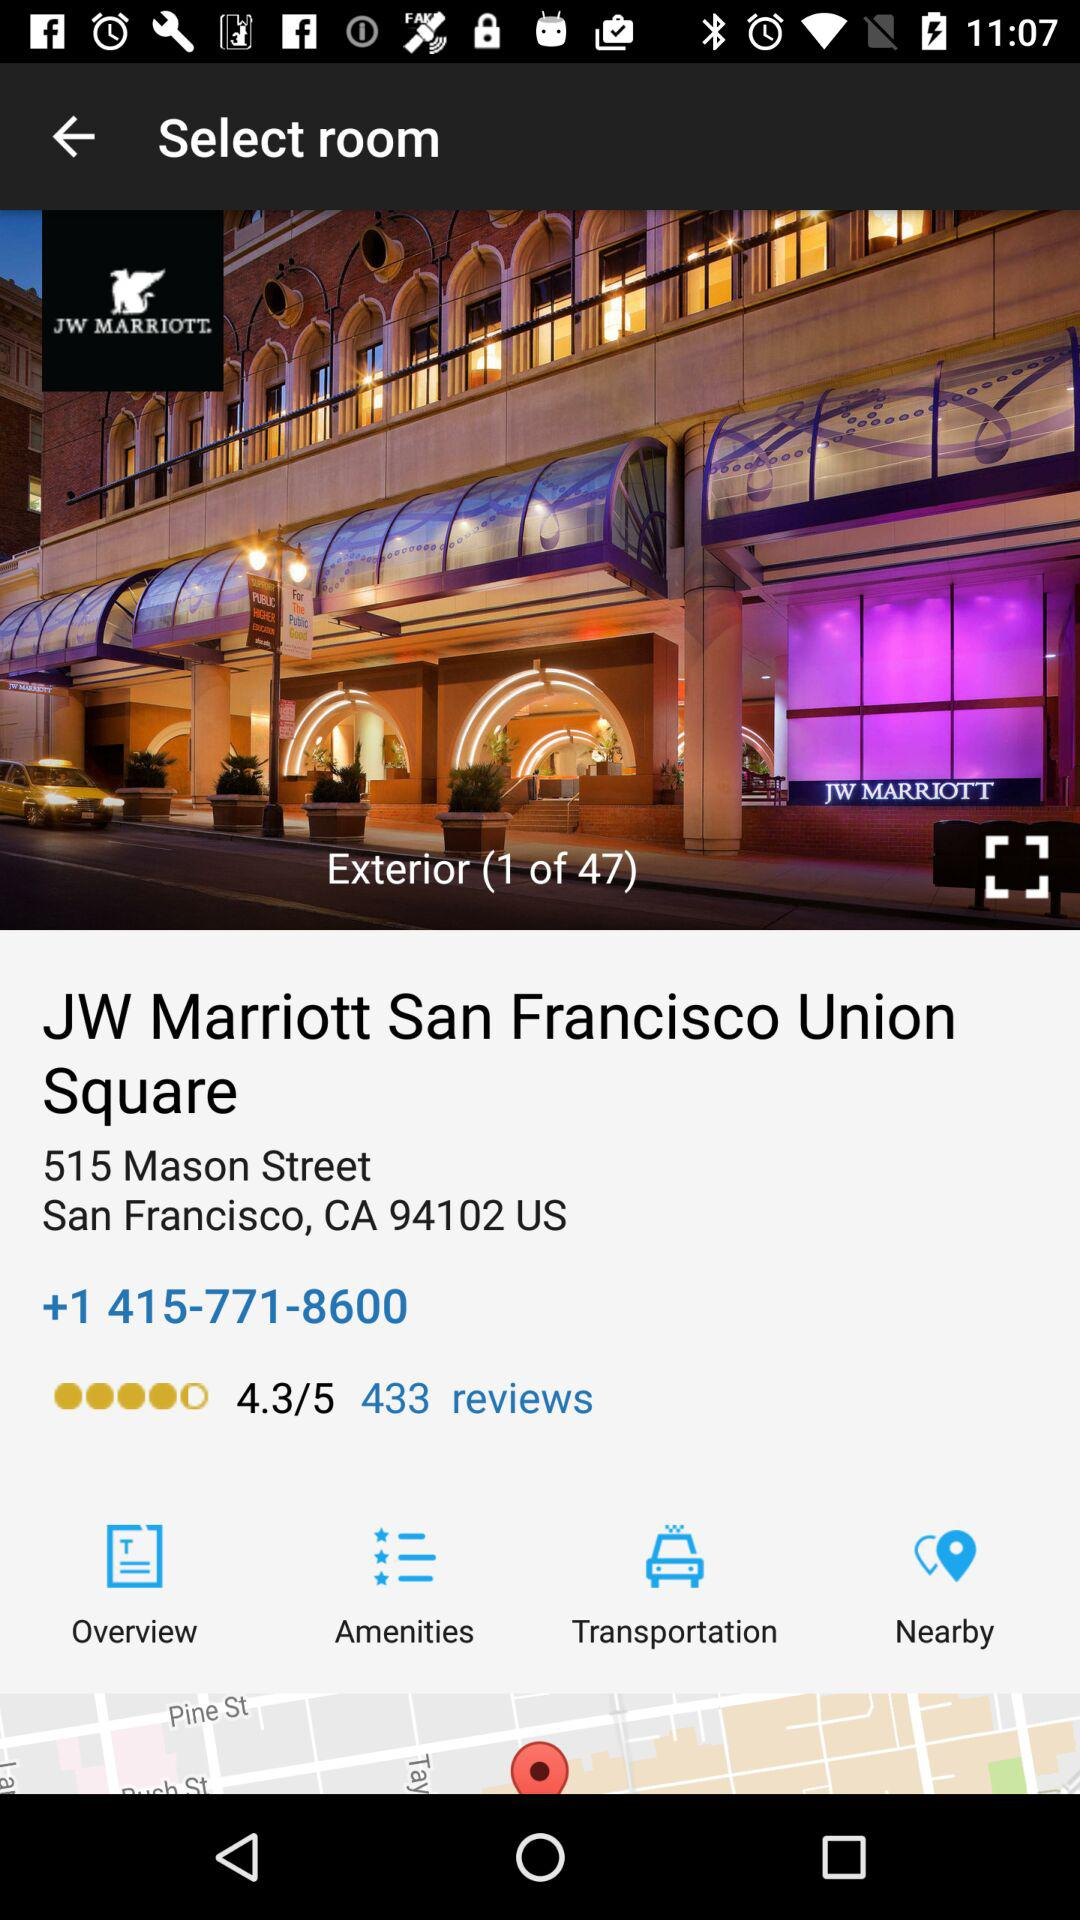What is the address of the JW Marriott San Francisco Union Square?
Answer the question using a single word or phrase. 515 Mason Street San Francisco, CA 94102 US 